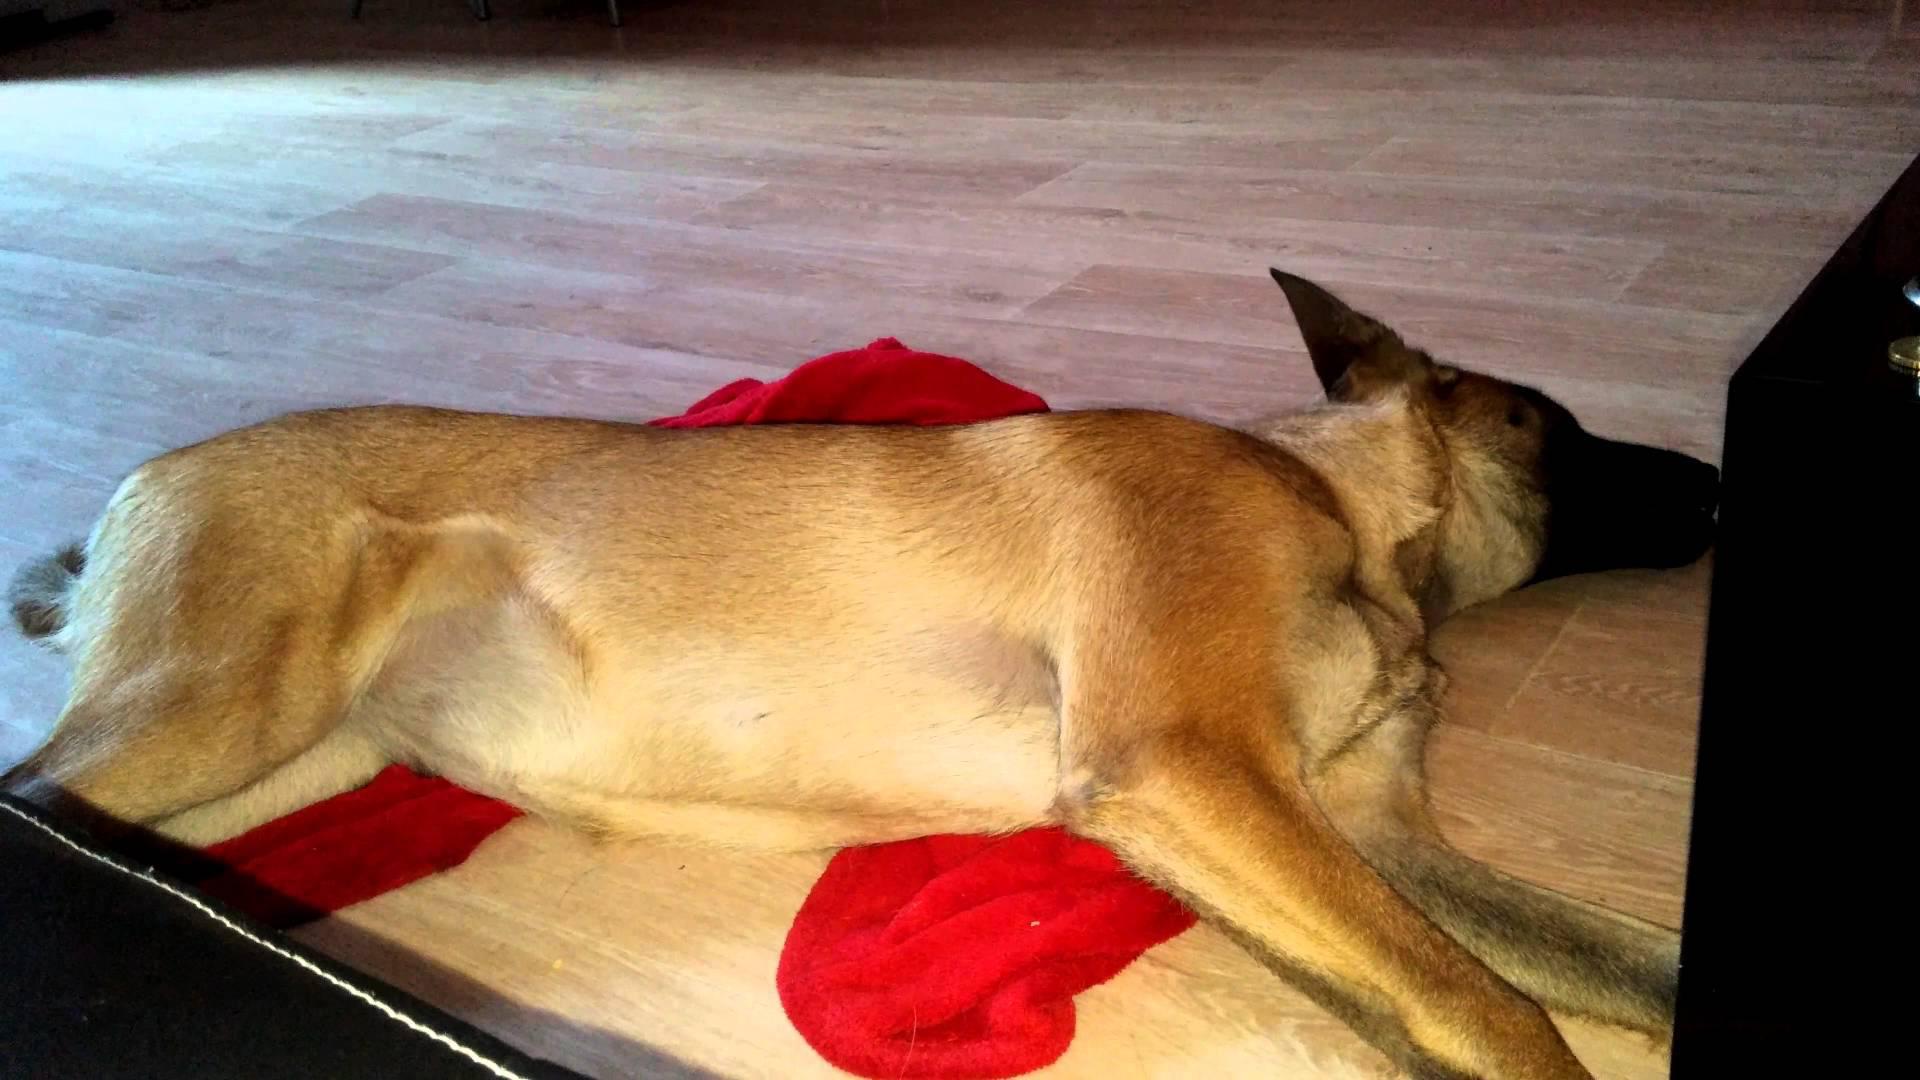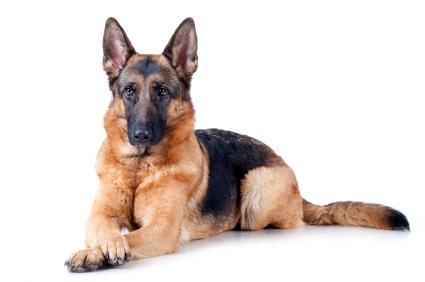The first image is the image on the left, the second image is the image on the right. Given the left and right images, does the statement "A dog and a cat are lying down together." hold true? Answer yes or no. No. The first image is the image on the left, the second image is the image on the right. Considering the images on both sides, is "An image shows a dog and a cat together in a resting pose." valid? Answer yes or no. No. 